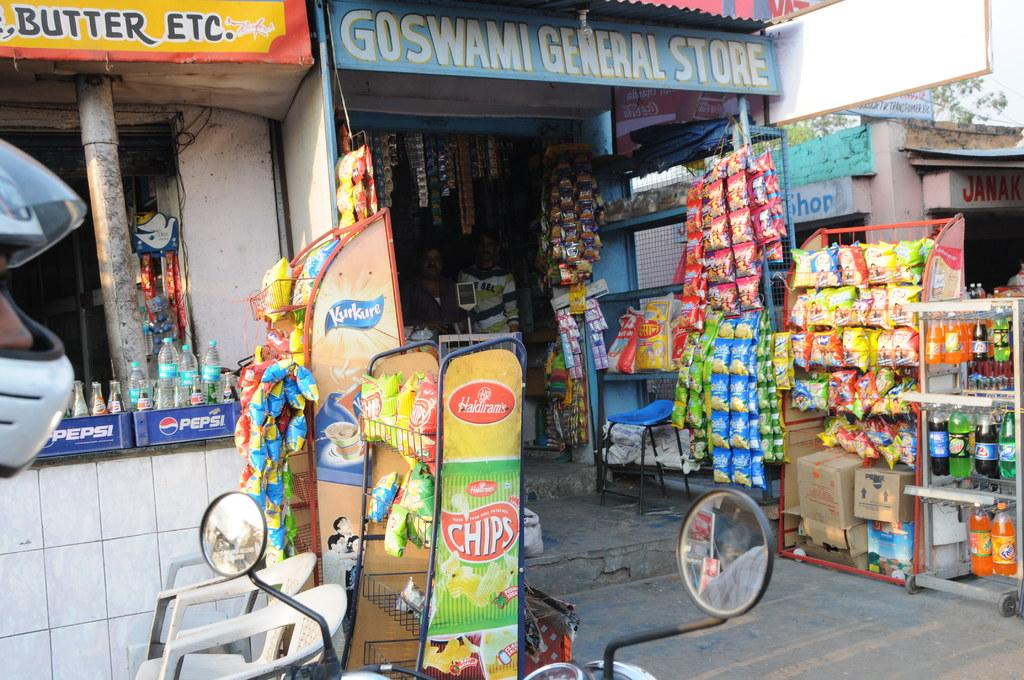Provide a one-sentence caption for the provided image. Pepsi, chips and other snack items are sold in small, run down shops. 